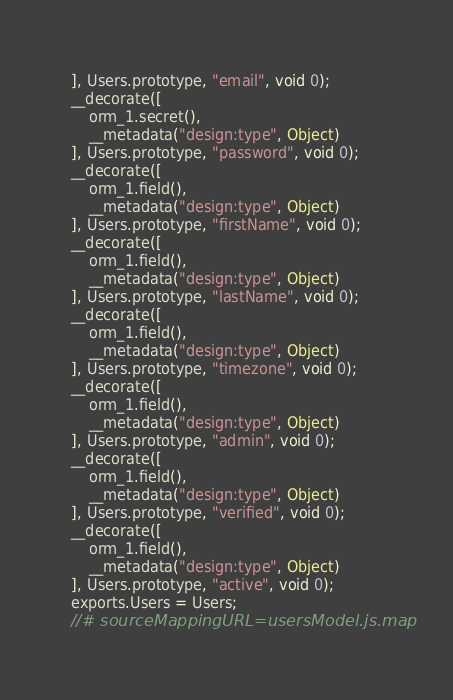<code> <loc_0><loc_0><loc_500><loc_500><_JavaScript_>], Users.prototype, "email", void 0);
__decorate([
    orm_1.secret(),
    __metadata("design:type", Object)
], Users.prototype, "password", void 0);
__decorate([
    orm_1.field(),
    __metadata("design:type", Object)
], Users.prototype, "firstName", void 0);
__decorate([
    orm_1.field(),
    __metadata("design:type", Object)
], Users.prototype, "lastName", void 0);
__decorate([
    orm_1.field(),
    __metadata("design:type", Object)
], Users.prototype, "timezone", void 0);
__decorate([
    orm_1.field(),
    __metadata("design:type", Object)
], Users.prototype, "admin", void 0);
__decorate([
    orm_1.field(),
    __metadata("design:type", Object)
], Users.prototype, "verified", void 0);
__decorate([
    orm_1.field(),
    __metadata("design:type", Object)
], Users.prototype, "active", void 0);
exports.Users = Users;
//# sourceMappingURL=usersModel.js.map</code> 